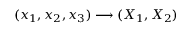<formula> <loc_0><loc_0><loc_500><loc_500>( x _ { 1 } , x _ { 2 } , x _ { 3 } ) \longrightarrow ( X _ { 1 } , X _ { 2 } )</formula> 